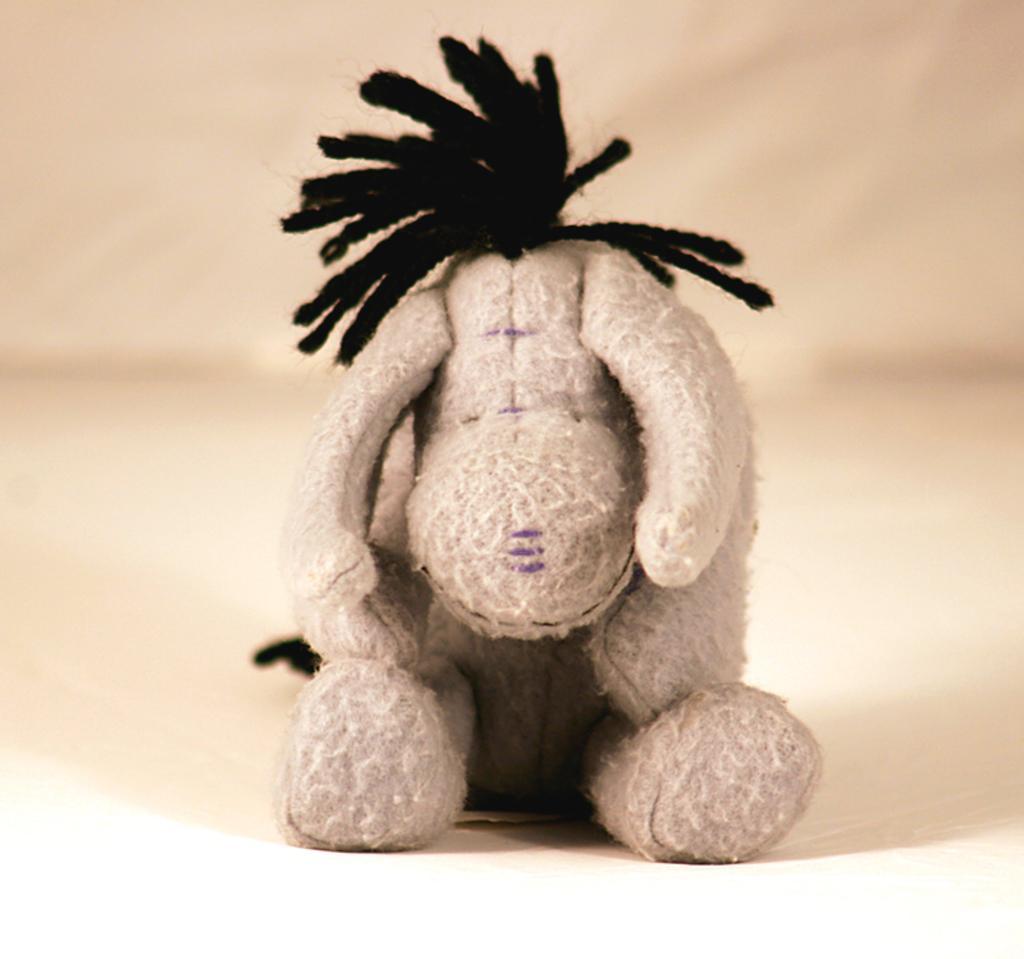How would you summarize this image in a sentence or two? In this image we can see a doll placed on the floor. 